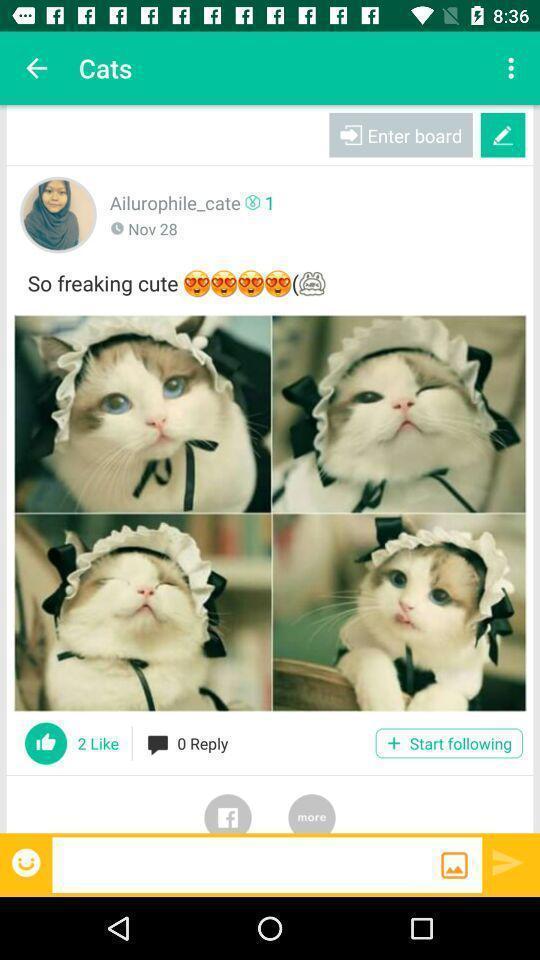Explain the elements present in this screenshot. Profile of user of so freaking cute. 